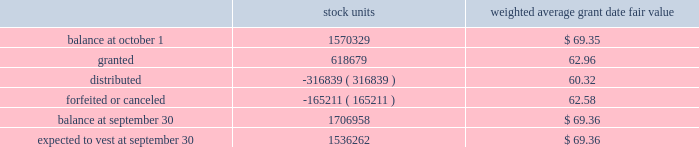The weighted average grant date fair value of performance-based restricted stock units granted during the years 2008 and 2007 was $ 84.33 and $ 71.72 , respectively .
The total fair value of performance-based restricted stock units vested during 2009 , 2008 and 2007 was $ 33712 , $ 49387 and $ 9181 , respectively .
At september 30 , 2009 , the weighted average remaining vesting term of performance-based restricted stock units is 1.28 years .
Time-vested restricted stock units time-vested restricted stock units generally cliff vest three years after the date of grant , except for certain key executives of the company , including the executive officers , for which such units generally vest one year following the employee 2019s retirement .
The related share-based compensation expense is recorded over the requisite service period , which is the vesting period or in the case of certain key executives is based on retirement eligibility .
The fair value of all time-vested restricted stock units is based on the market value of the company 2019s stock on the date of grant .
A summary of time-vested restricted stock units outstanding as of september 30 , 2009 , and changes during the year then ended is as follows : weighted average grant date fair value .
The weighted average grant date fair value of time-vested restricted stock units granted during the years 2008 and 2007 was $ 84.42 and $ 72.20 , respectively .
The total fair value of time-vested restricted stock units vested during 2009 , 2008 and 2007 was $ 29535 , $ 26674 and $ 3392 , respectively .
At september 30 , 2009 , the weighted average remaining vesting term of the time-vested restricted stock units is 1.71 years .
The amount of unrecognized compensation expense for all non-vested share-based awards as of september 30 , 2009 , is approximately $ 97034 , which is expected to be recognized over a weighted-average remaining life of approximately 2.02 years .
At september 30 , 2009 , 4295402 shares were authorized for future grants under the 2004 plan .
The company has a policy of satisfying share-based payments through either open market purchases or shares held in treasury .
At september 30 , 2009 , the company has sufficient shares held in treasury to satisfy these payments in 2010 .
Other stock plans the company has a stock award plan , which allows for grants of common shares to certain key employees .
Distribution of 25% ( 25 % ) or more of each award is deferred until after retirement or involuntary termination , upon which the deferred portion of the award is distributable in five equal annual installments .
The balance of the award is distributable over five years from the grant date , subject to certain conditions .
In february 2004 , this plan was terminated with respect to future grants upon the adoption of the 2004 plan .
At september 30 , 2009 and 2008 , awards for 114197 and 161145 shares , respectively , were outstanding .
Becton , dickinson and company notes to consolidated financial statements 2014 ( continued ) .
What was the average the total fair value of performance-based restricted stock units vested from 2007 to 2009? 
Computations: (((33712 + 49387) + 9181) / 3)
Answer: 30760.0. 